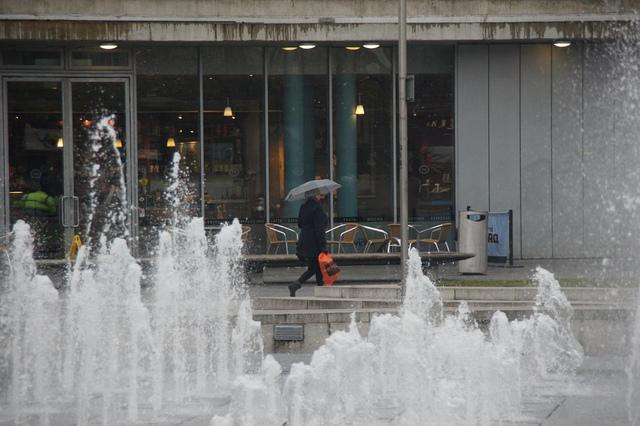Why is this person using an umbrella?
Concise answer only. Rain. Why is water shooting from the ground?
Concise answer only. Fountain. What color is the person's outfit?
Be succinct. Black. 